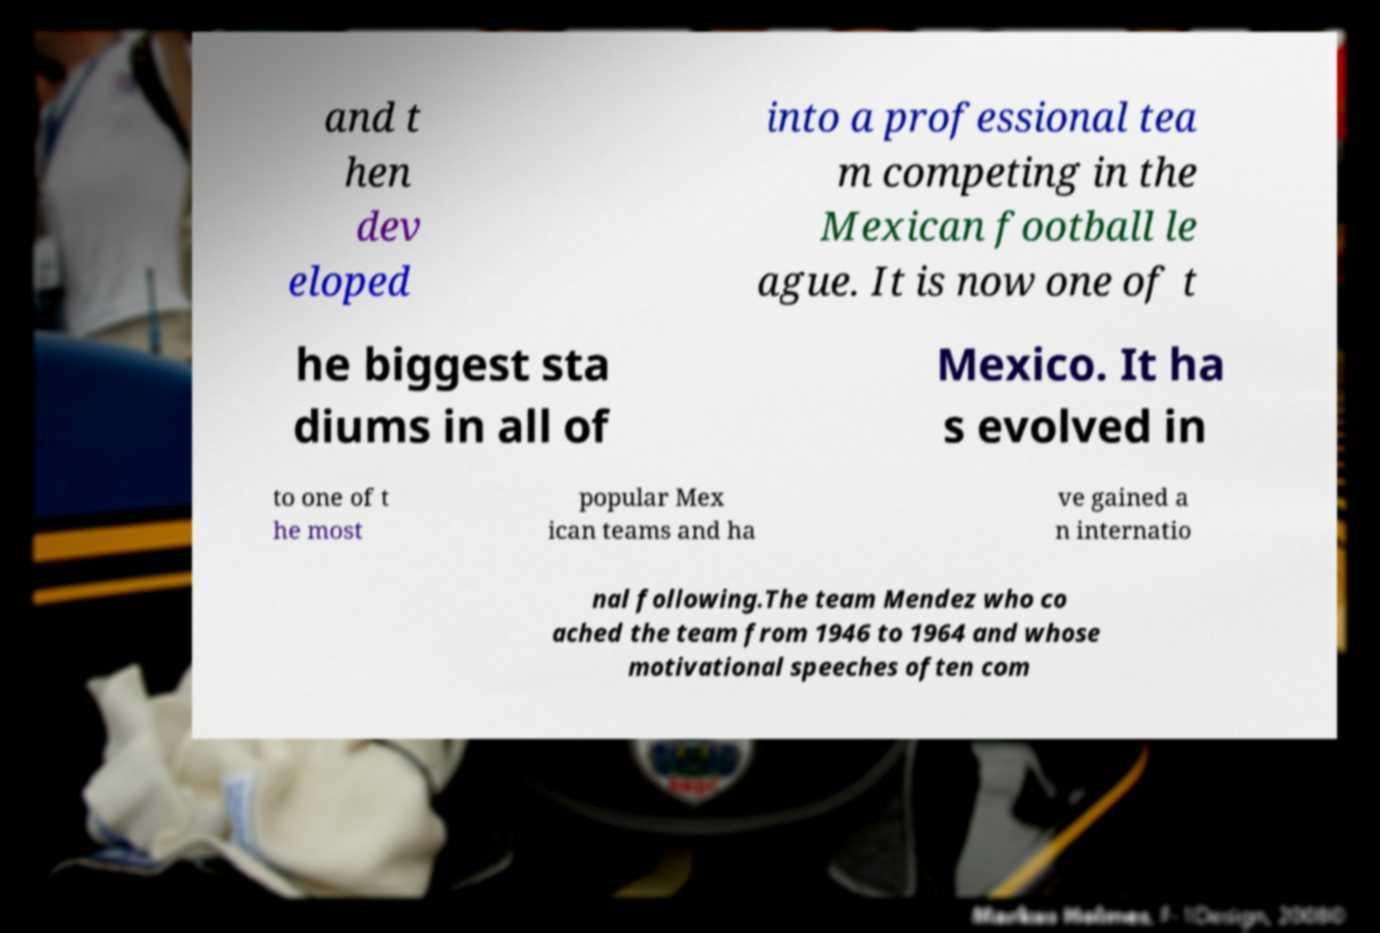For documentation purposes, I need the text within this image transcribed. Could you provide that? and t hen dev eloped into a professional tea m competing in the Mexican football le ague. It is now one of t he biggest sta diums in all of Mexico. It ha s evolved in to one of t he most popular Mex ican teams and ha ve gained a n internatio nal following.The team Mendez who co ached the team from 1946 to 1964 and whose motivational speeches often com 